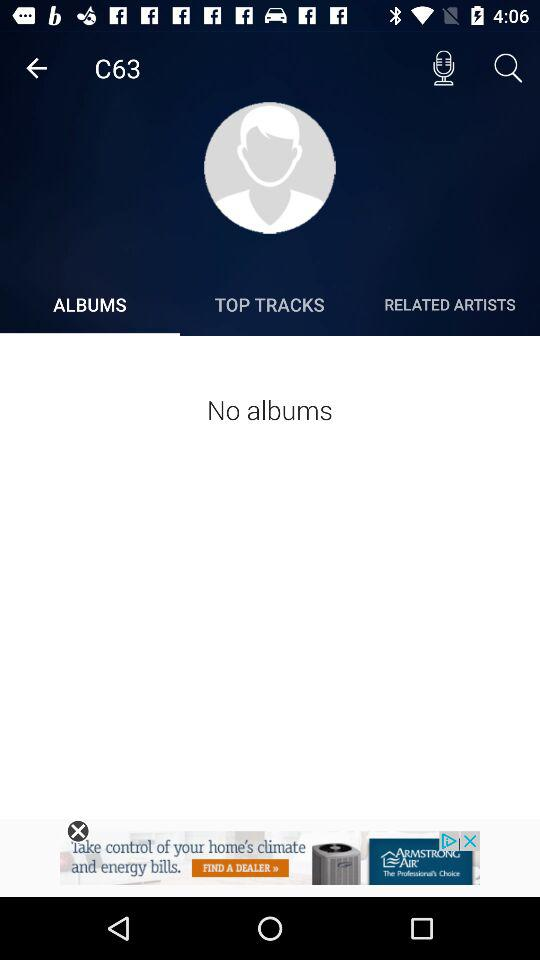Which tab has been selected? The tab that has been selected is "ALBUMS". 